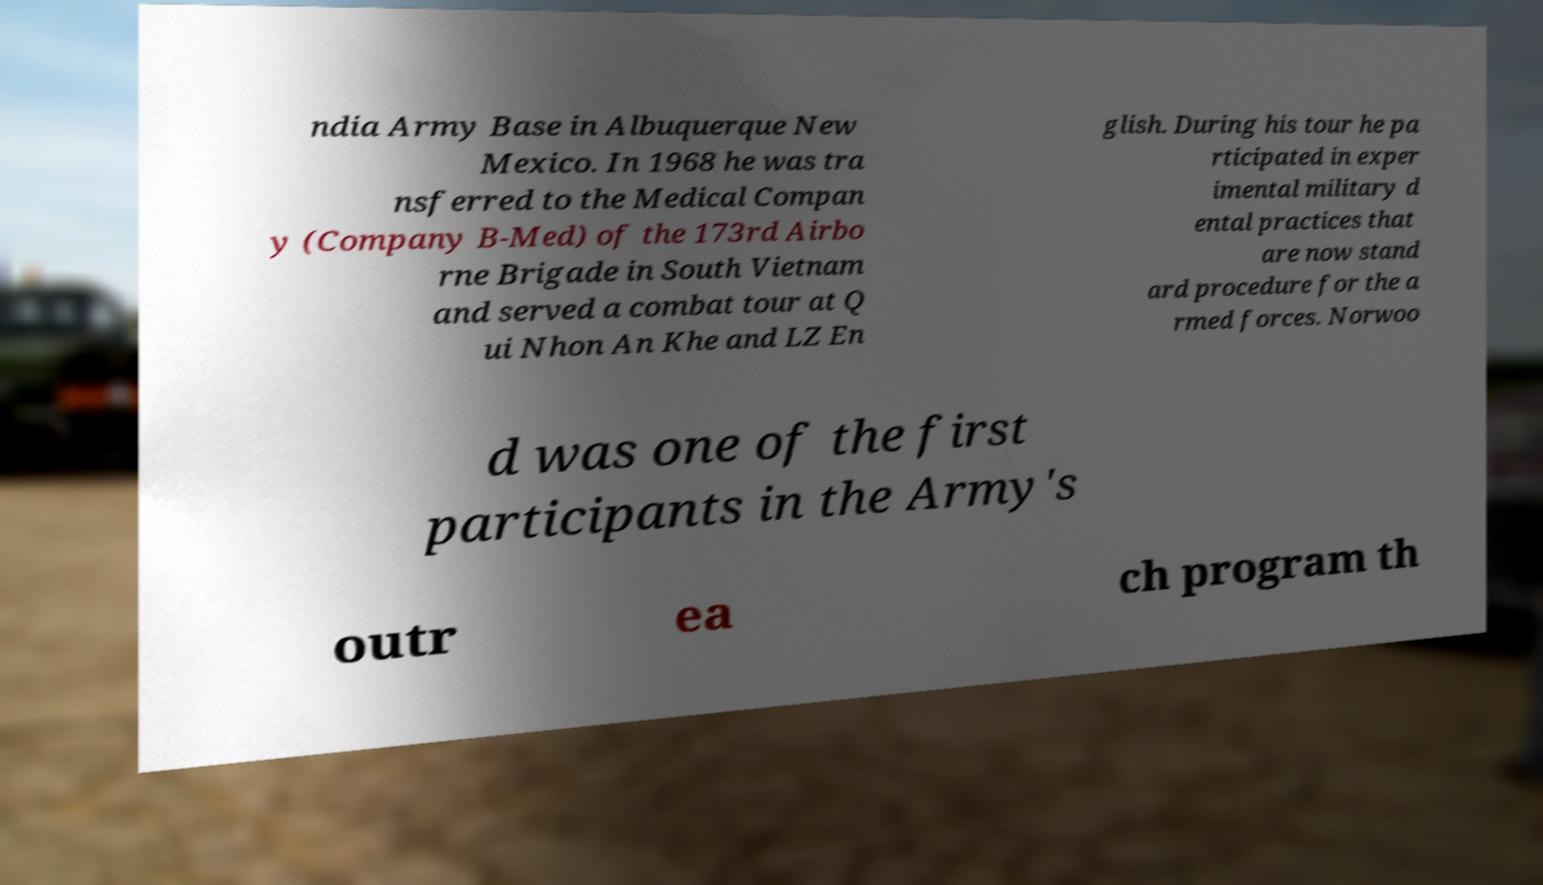There's text embedded in this image that I need extracted. Can you transcribe it verbatim? ndia Army Base in Albuquerque New Mexico. In 1968 he was tra nsferred to the Medical Compan y (Company B-Med) of the 173rd Airbo rne Brigade in South Vietnam and served a combat tour at Q ui Nhon An Khe and LZ En glish. During his tour he pa rticipated in exper imental military d ental practices that are now stand ard procedure for the a rmed forces. Norwoo d was one of the first participants in the Army's outr ea ch program th 